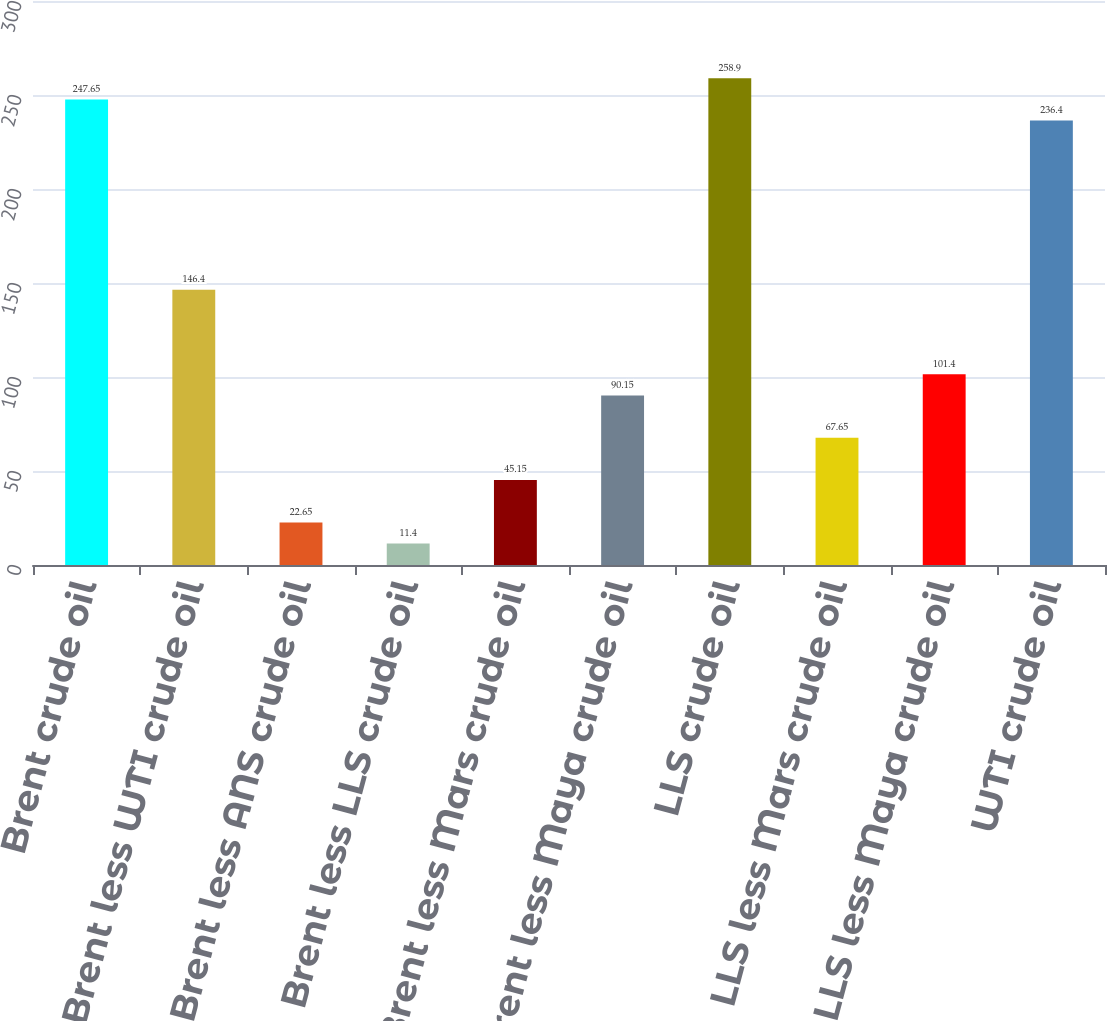Convert chart to OTSL. <chart><loc_0><loc_0><loc_500><loc_500><bar_chart><fcel>Brent crude oil<fcel>Brent less WTI crude oil<fcel>Brent less ANS crude oil<fcel>Brent less LLS crude oil<fcel>Brent less Mars crude oil<fcel>Brent less Maya crude oil<fcel>LLS crude oil<fcel>LLS less Mars crude oil<fcel>LLS less Maya crude oil<fcel>WTI crude oil<nl><fcel>247.65<fcel>146.4<fcel>22.65<fcel>11.4<fcel>45.15<fcel>90.15<fcel>258.9<fcel>67.65<fcel>101.4<fcel>236.4<nl></chart> 